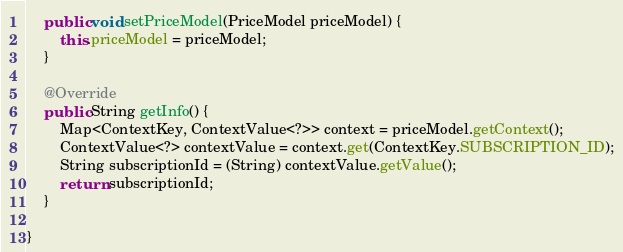<code> <loc_0><loc_0><loc_500><loc_500><_Java_>
    public void setPriceModel(PriceModel priceModel) {
        this.priceModel = priceModel;
    }

    @Override
    public String getInfo() {
        Map<ContextKey, ContextValue<?>> context = priceModel.getContext();
        ContextValue<?> contextValue = context.get(ContextKey.SUBSCRIPTION_ID);
        String subscriptionId = (String) contextValue.getValue();
        return subscriptionId;
    }

}
</code> 